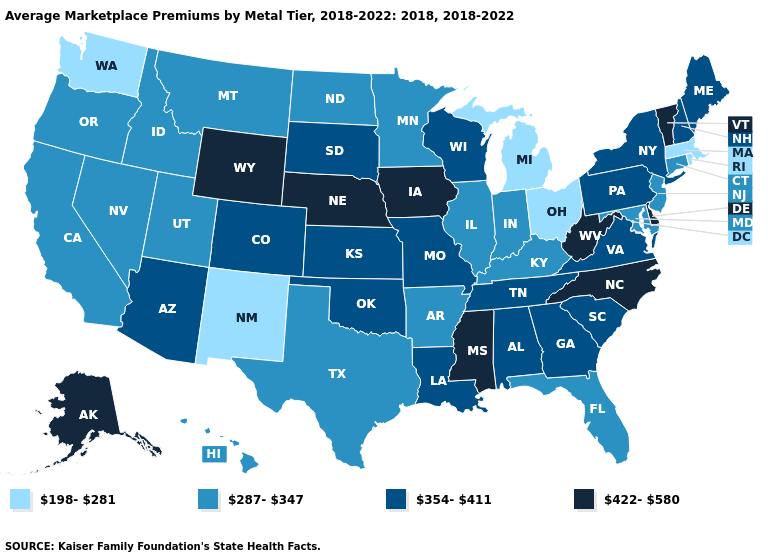Does the first symbol in the legend represent the smallest category?
Keep it brief. Yes. What is the lowest value in the USA?
Keep it brief. 198-281. Does New Mexico have the lowest value in the USA?
Keep it brief. Yes. Does the first symbol in the legend represent the smallest category?
Give a very brief answer. Yes. What is the value of Indiana?
Write a very short answer. 287-347. Does South Carolina have a lower value than Mississippi?
Answer briefly. Yes. Does Massachusetts have the lowest value in the USA?
Answer briefly. Yes. What is the highest value in states that border Iowa?
Be succinct. 422-580. Name the states that have a value in the range 198-281?
Answer briefly. Massachusetts, Michigan, New Mexico, Ohio, Rhode Island, Washington. Which states have the highest value in the USA?
Answer briefly. Alaska, Delaware, Iowa, Mississippi, Nebraska, North Carolina, Vermont, West Virginia, Wyoming. Name the states that have a value in the range 287-347?
Write a very short answer. Arkansas, California, Connecticut, Florida, Hawaii, Idaho, Illinois, Indiana, Kentucky, Maryland, Minnesota, Montana, Nevada, New Jersey, North Dakota, Oregon, Texas, Utah. What is the highest value in the South ?
Keep it brief. 422-580. Which states hav the highest value in the MidWest?
Keep it brief. Iowa, Nebraska. Name the states that have a value in the range 198-281?
Quick response, please. Massachusetts, Michigan, New Mexico, Ohio, Rhode Island, Washington. What is the value of Oklahoma?
Concise answer only. 354-411. 